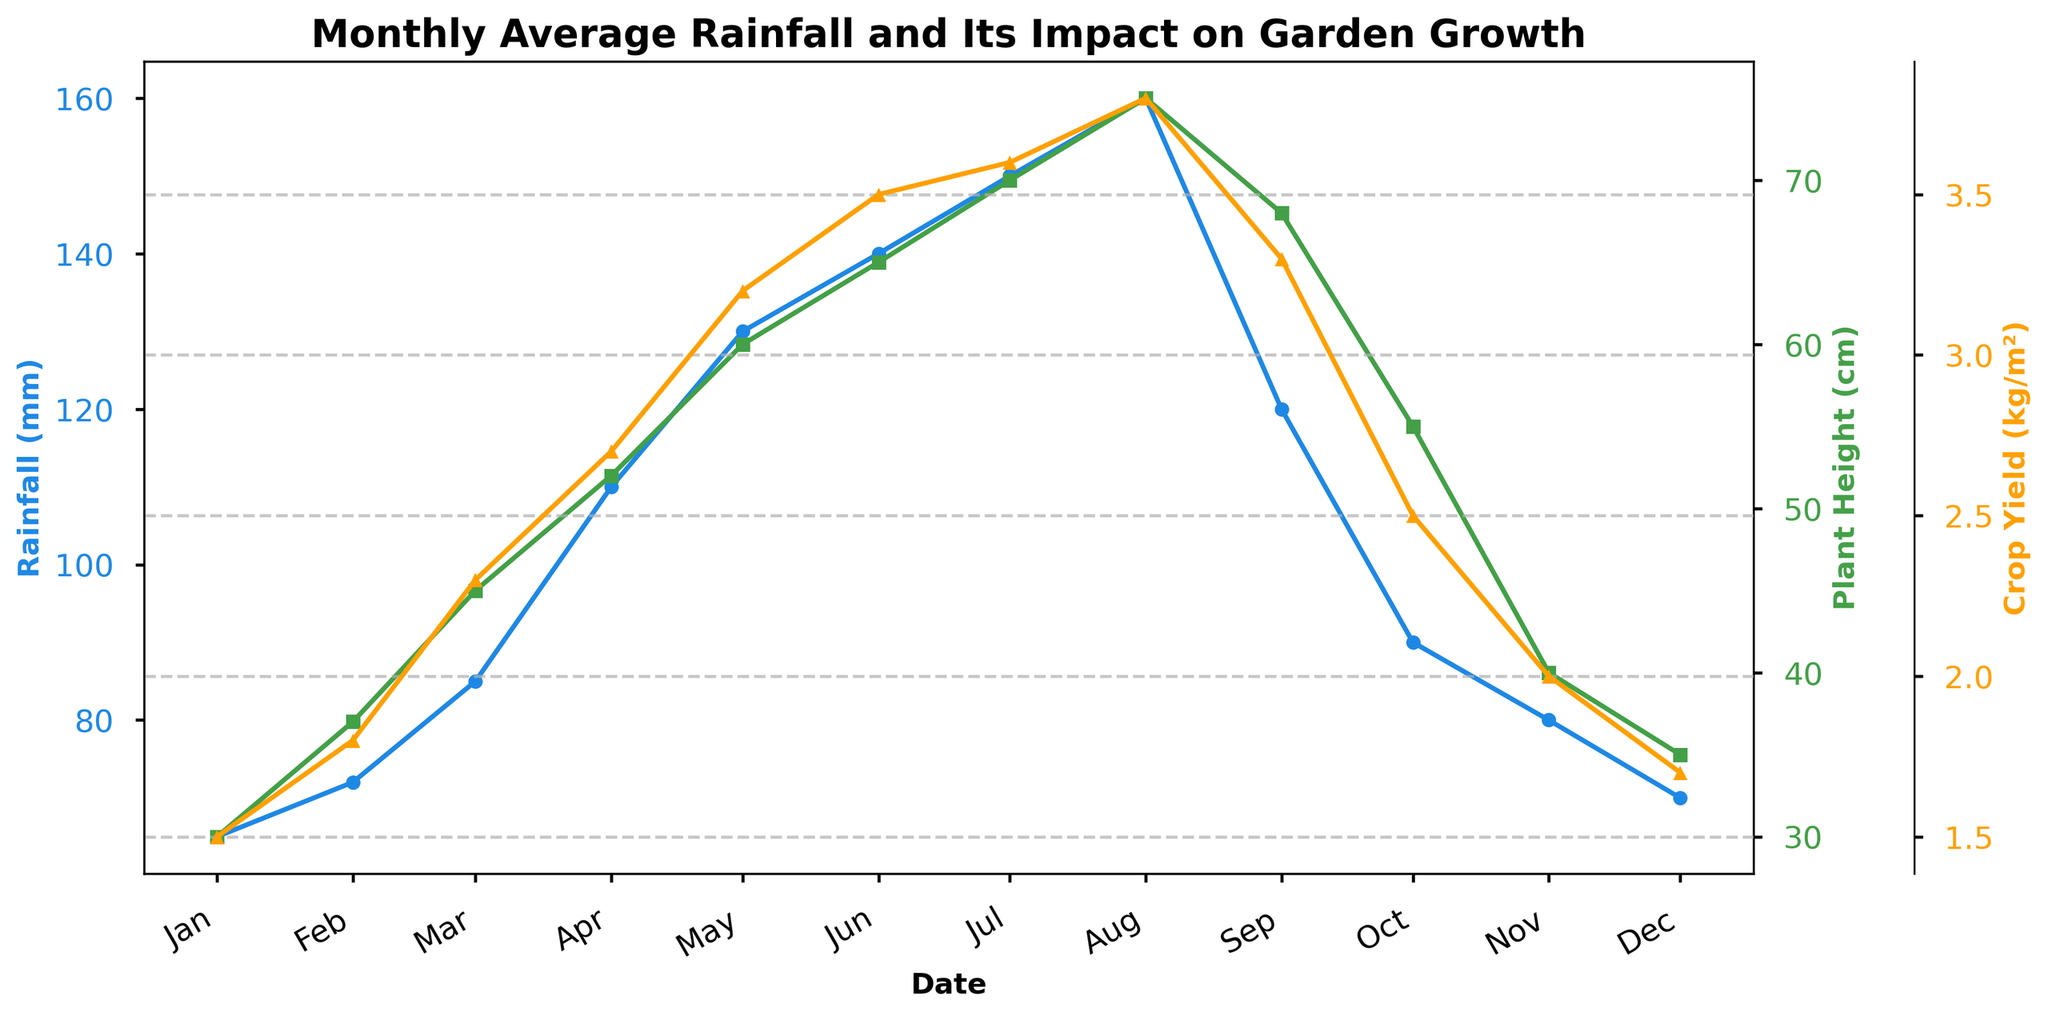What is the title of the figure? The title is usually at the top of the figure and summarizes the main insight. Here, the title is "Monthly Average Rainfall and Its Impact on Garden Growth".
Answer: Monthly Average Rainfall and Its Impact on Garden Growth What are the three variables plotted in the figure? By examining the y-axes and the plotted lines, we can see that the three variables are Monthly Average Rainfall (mm), Plant Height (cm), and Crop Yield (kg/m²).
Answer: Monthly Average Rainfall (mm), Plant Height (cm), and Crop Yield (kg/m²) When does the Crop Yield reach its highest value? By looking at the Crop Yield curve, we can identify that it reaches its highest value in August.
Answer: August What can be inferred about Plant Height and Rainfall in June? From the plot, we can see that in June, the Monthly Average Rainfall is 140 mm and the Plant Height is 65 cm.
Answer: Rainfall: 140 mm, Plant Height: 65 cm Which month shows the sharpest increase in Plant Height? Observing the Plant Height curve, the sharpest increase occurs between February and March.
Answer: Between February and March What is the difference in Crop Yield between May and October? In May, the Crop Yield is 3.2 kg/m², and in October, it is 2.5 kg/m². The difference is calculated as 3.2 - 2.5 = 0.7 kg/m².
Answer: 0.7 kg/m² During which months does the Monthly Average Rainfall exceed 100 mm? The plot indicates that the Monthly Average Rainfall exceeds 100 mm from April to August.
Answer: April, May, June, July, August Is there a correlation between Monthly Average Rainfall and Plant Height? By observing the trends, as the Monthly Average Rainfall increases, the Plant Height also tends to increase, suggesting a positive correlation.
Answer: Positive correlation Which variable shows the most variation over the year? By comparing the range and fluctuation in the plotted lines, the Monthly Average Rainfall shows the most variation from 65 mm to 160 mm.
Answer: Monthly Average Rainfall How does the Crop Yield change from July to August? From July to August, the Crop Yield increases from 3.6 kg/m² to 3.8 kg/m².
Answer: Increases from 3.6 kg/m² to 3.8 kg/m² 